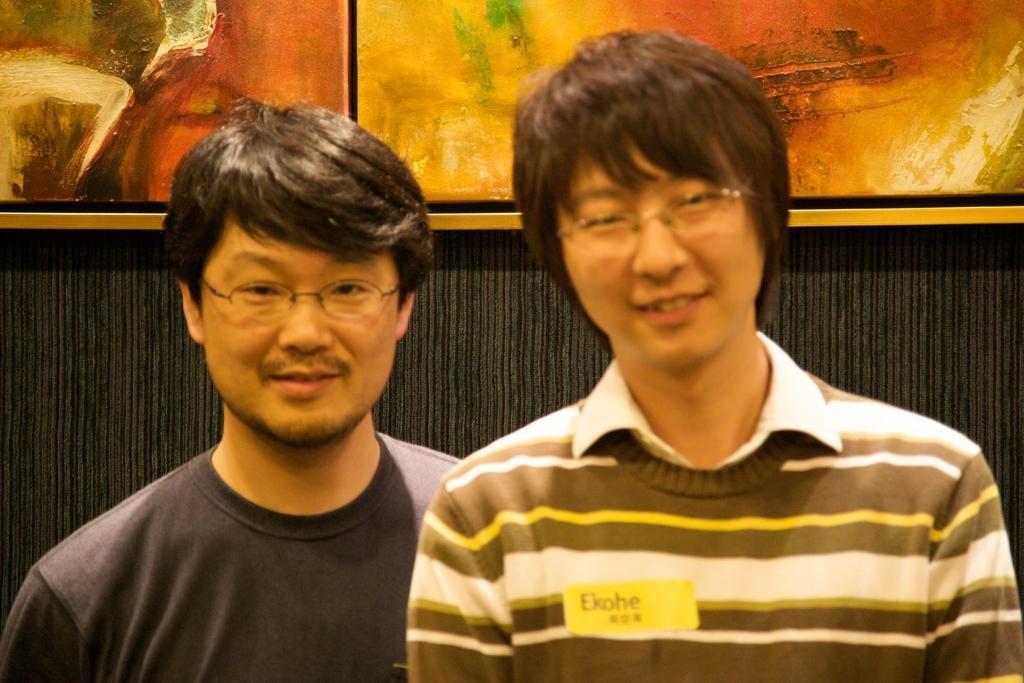Please provide a concise description of this image. In this image I can see there are persons standing with smiling. And at the back it looks like a wall. And to that wall there are painting boards. 